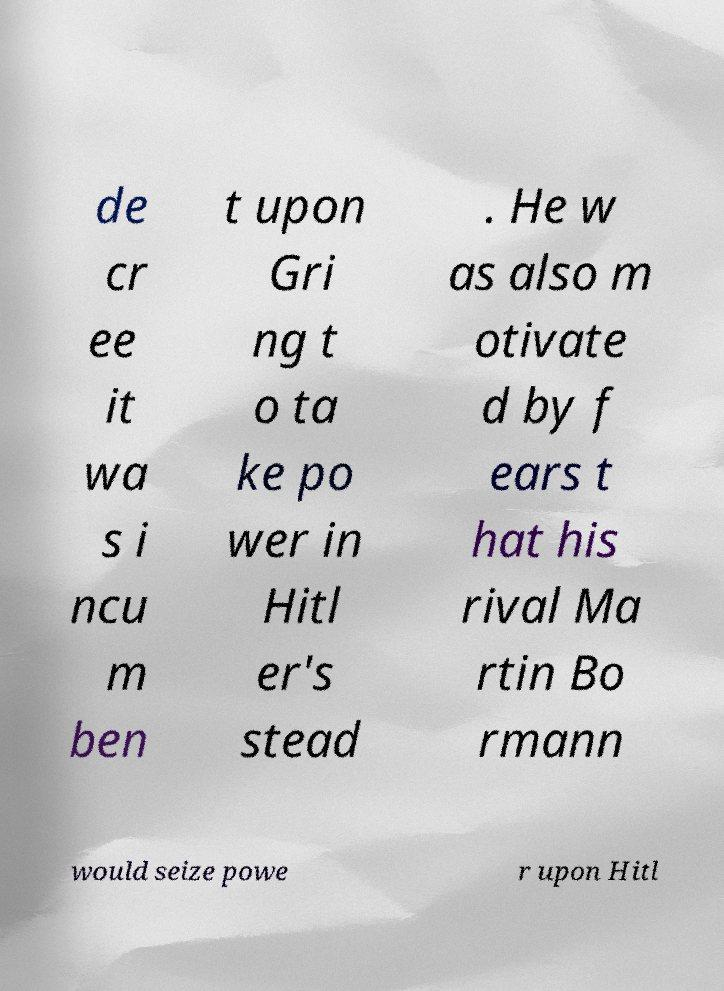I need the written content from this picture converted into text. Can you do that? de cr ee it wa s i ncu m ben t upon Gri ng t o ta ke po wer in Hitl er's stead . He w as also m otivate d by f ears t hat his rival Ma rtin Bo rmann would seize powe r upon Hitl 